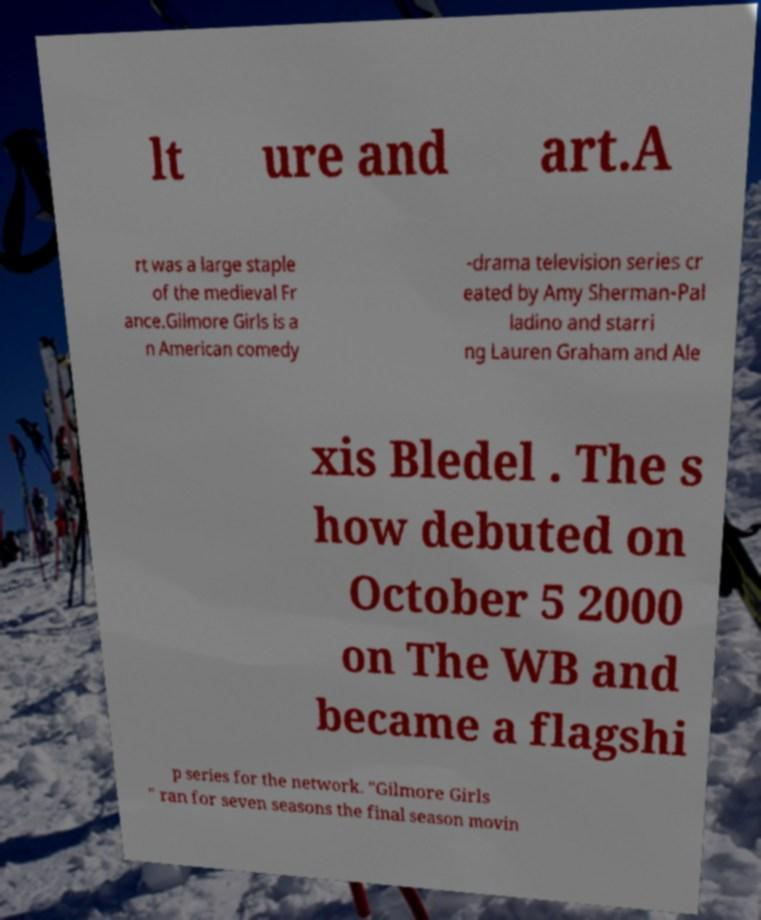Please identify and transcribe the text found in this image. lt ure and art.A rt was a large staple of the medieval Fr ance.Gilmore Girls is a n American comedy -drama television series cr eated by Amy Sherman-Pal ladino and starri ng Lauren Graham and Ale xis Bledel . The s how debuted on October 5 2000 on The WB and became a flagshi p series for the network. "Gilmore Girls " ran for seven seasons the final season movin 